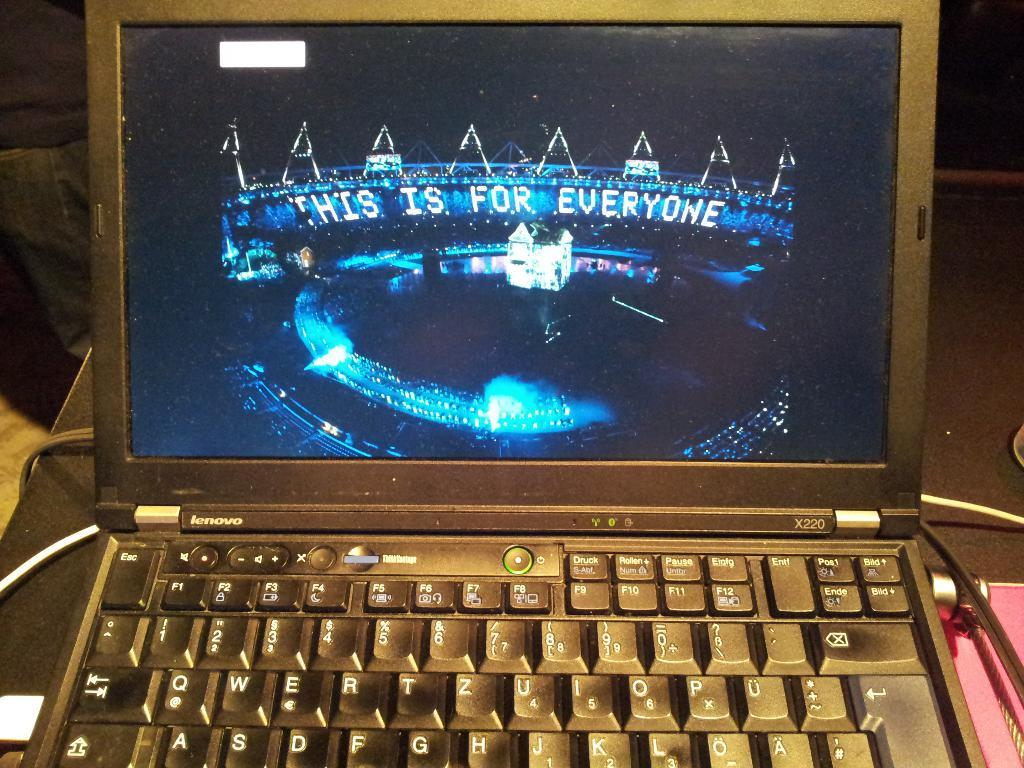<image>
Provide a brief description of the given image. A laptop with a screen displaying the words This is for Everyone 